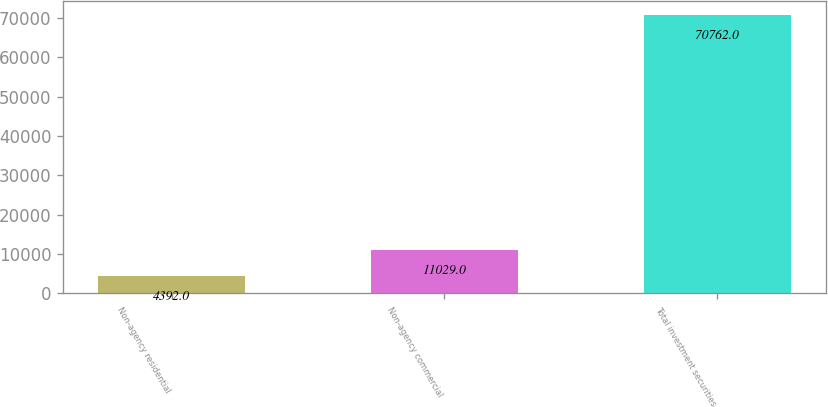<chart> <loc_0><loc_0><loc_500><loc_500><bar_chart><fcel>Non-agency residential<fcel>Non-agency commercial<fcel>Total investment securities<nl><fcel>4392<fcel>11029<fcel>70762<nl></chart> 